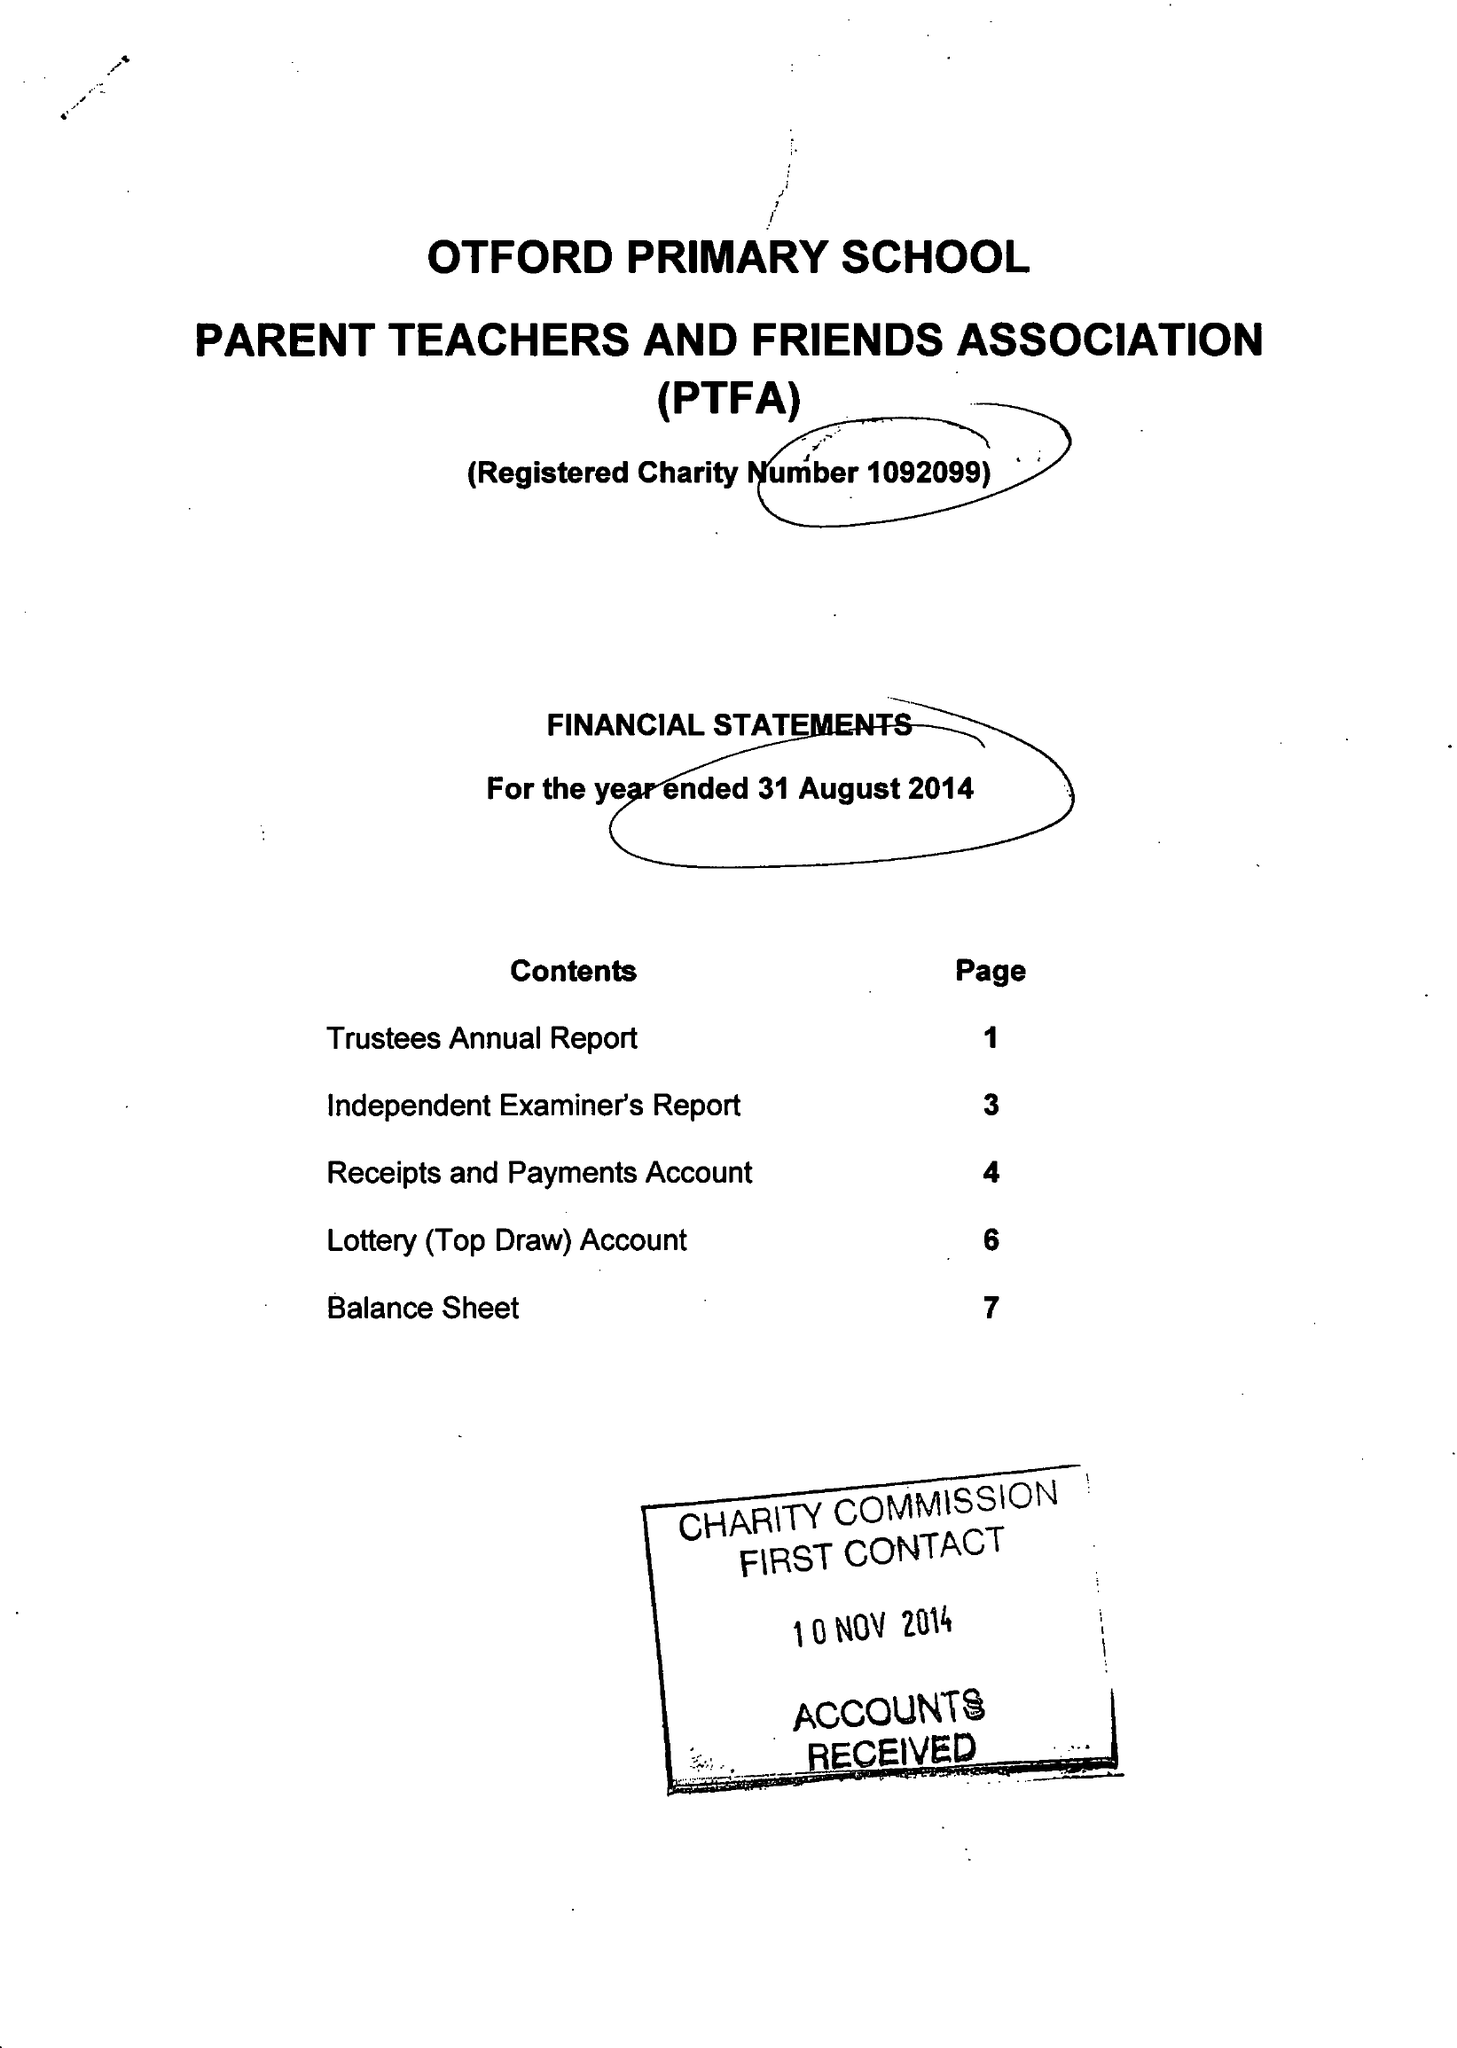What is the value for the charity_number?
Answer the question using a single word or phrase. 1092099 